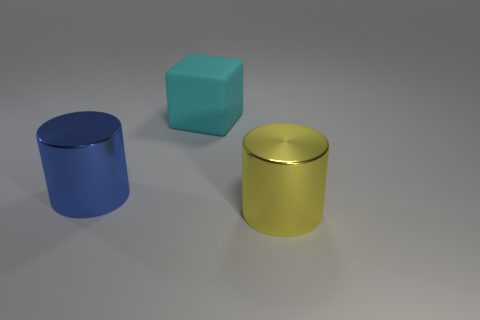Add 1 big blue objects. How many objects exist? 4 Subtract all blocks. How many objects are left? 2 Add 2 yellow things. How many yellow things exist? 3 Subtract 0 green cylinders. How many objects are left? 3 Subtract all yellow metallic objects. Subtract all blue cylinders. How many objects are left? 1 Add 2 large blue shiny cylinders. How many large blue shiny cylinders are left? 3 